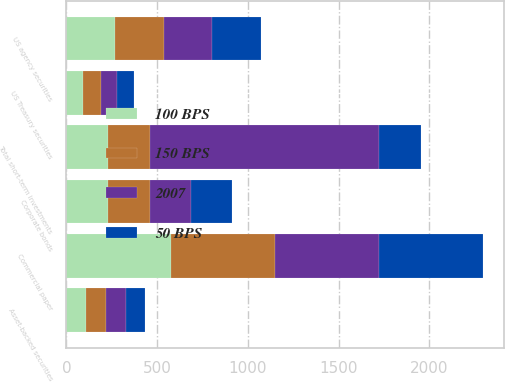Convert chart to OTSL. <chart><loc_0><loc_0><loc_500><loc_500><stacked_bar_chart><ecel><fcel>Commercial paper<fcel>US agency securities<fcel>Corporate bonds<fcel>Asset-backed securities<fcel>US Treasury securities<fcel>Total short-term investments<nl><fcel>150 BPS<fcel>575<fcel>271<fcel>231<fcel>110<fcel>95<fcel>230<nl><fcel>100 BPS<fcel>575<fcel>269<fcel>230<fcel>109<fcel>94<fcel>230<nl><fcel>50 BPS<fcel>574<fcel>267<fcel>228<fcel>108<fcel>94<fcel>230<nl><fcel>2007<fcel>574<fcel>264<fcel>226<fcel>108<fcel>92<fcel>1264<nl></chart> 